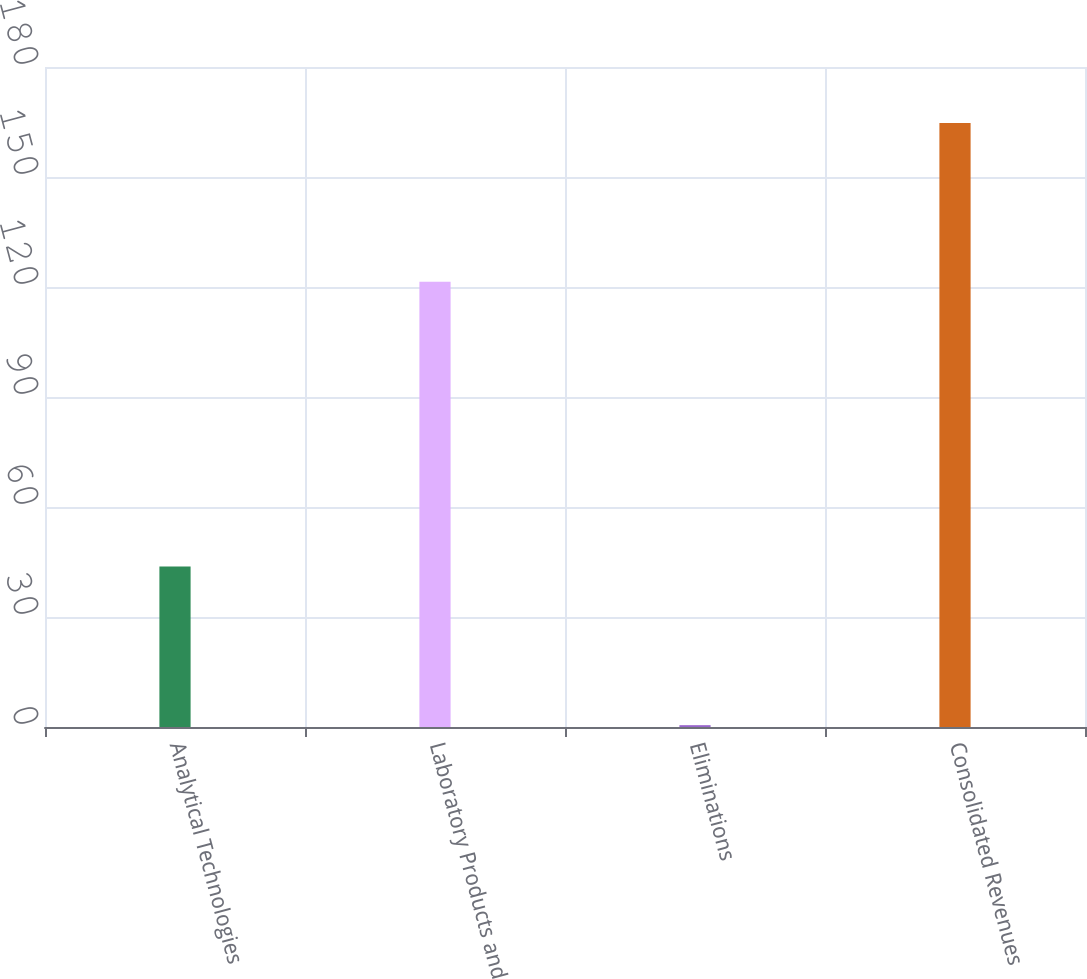Convert chart. <chart><loc_0><loc_0><loc_500><loc_500><bar_chart><fcel>Analytical Technologies<fcel>Laboratory Products and<fcel>Eliminations<fcel>Consolidated Revenues<nl><fcel>43.8<fcel>121.4<fcel>0.5<fcel>164.7<nl></chart> 